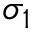Convert formula to latex. <formula><loc_0><loc_0><loc_500><loc_500>\sigma _ { 1 }</formula> 